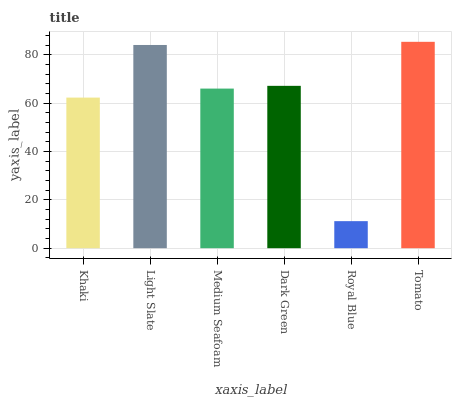Is Royal Blue the minimum?
Answer yes or no. Yes. Is Tomato the maximum?
Answer yes or no. Yes. Is Light Slate the minimum?
Answer yes or no. No. Is Light Slate the maximum?
Answer yes or no. No. Is Light Slate greater than Khaki?
Answer yes or no. Yes. Is Khaki less than Light Slate?
Answer yes or no. Yes. Is Khaki greater than Light Slate?
Answer yes or no. No. Is Light Slate less than Khaki?
Answer yes or no. No. Is Dark Green the high median?
Answer yes or no. Yes. Is Medium Seafoam the low median?
Answer yes or no. Yes. Is Royal Blue the high median?
Answer yes or no. No. Is Dark Green the low median?
Answer yes or no. No. 